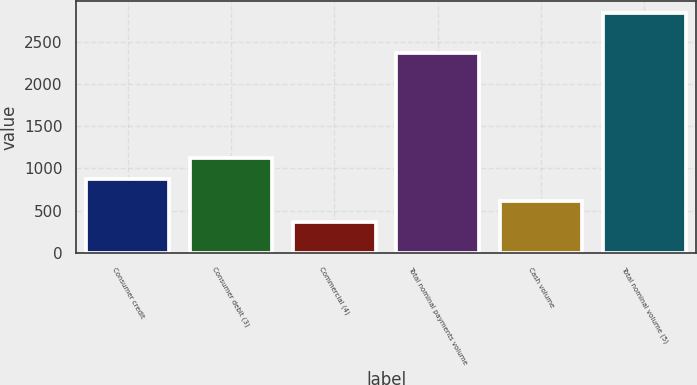Convert chart to OTSL. <chart><loc_0><loc_0><loc_500><loc_500><bar_chart><fcel>Consumer credit<fcel>Consumer debit (3)<fcel>Commercial (4)<fcel>Total nominal payments volume<fcel>Cash volume<fcel>Total nominal volume (5)<nl><fcel>872<fcel>1127<fcel>370<fcel>2369<fcel>616.7<fcel>2837<nl></chart> 